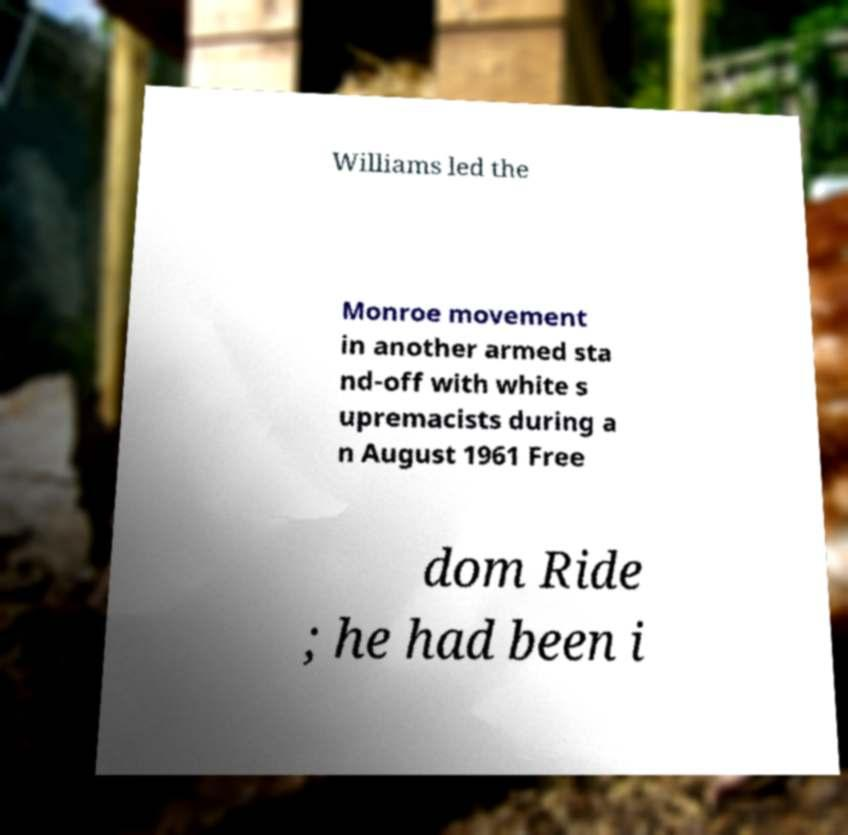What messages or text are displayed in this image? I need them in a readable, typed format. Williams led the Monroe movement in another armed sta nd-off with white s upremacists during a n August 1961 Free dom Ride ; he had been i 